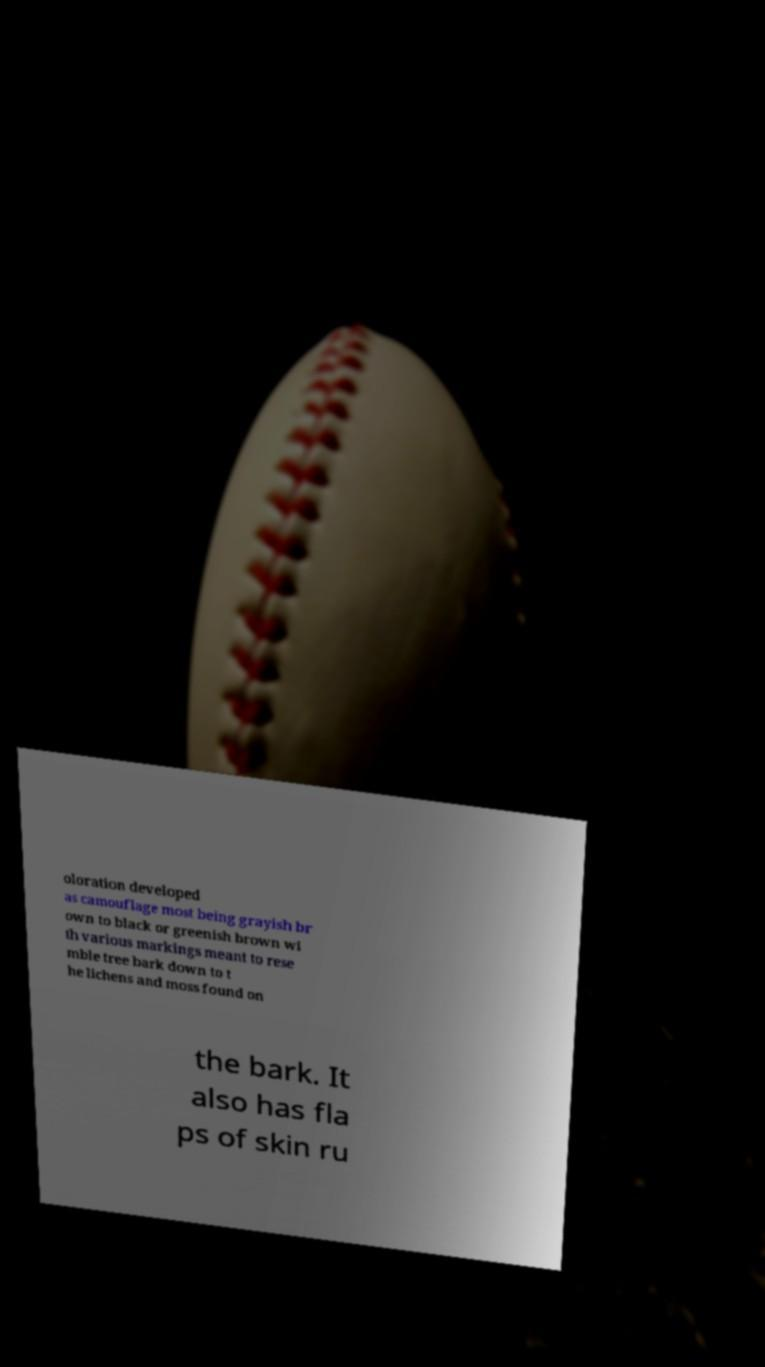Can you read and provide the text displayed in the image?This photo seems to have some interesting text. Can you extract and type it out for me? oloration developed as camouflage most being grayish br own to black or greenish brown wi th various markings meant to rese mble tree bark down to t he lichens and moss found on the bark. It also has fla ps of skin ru 